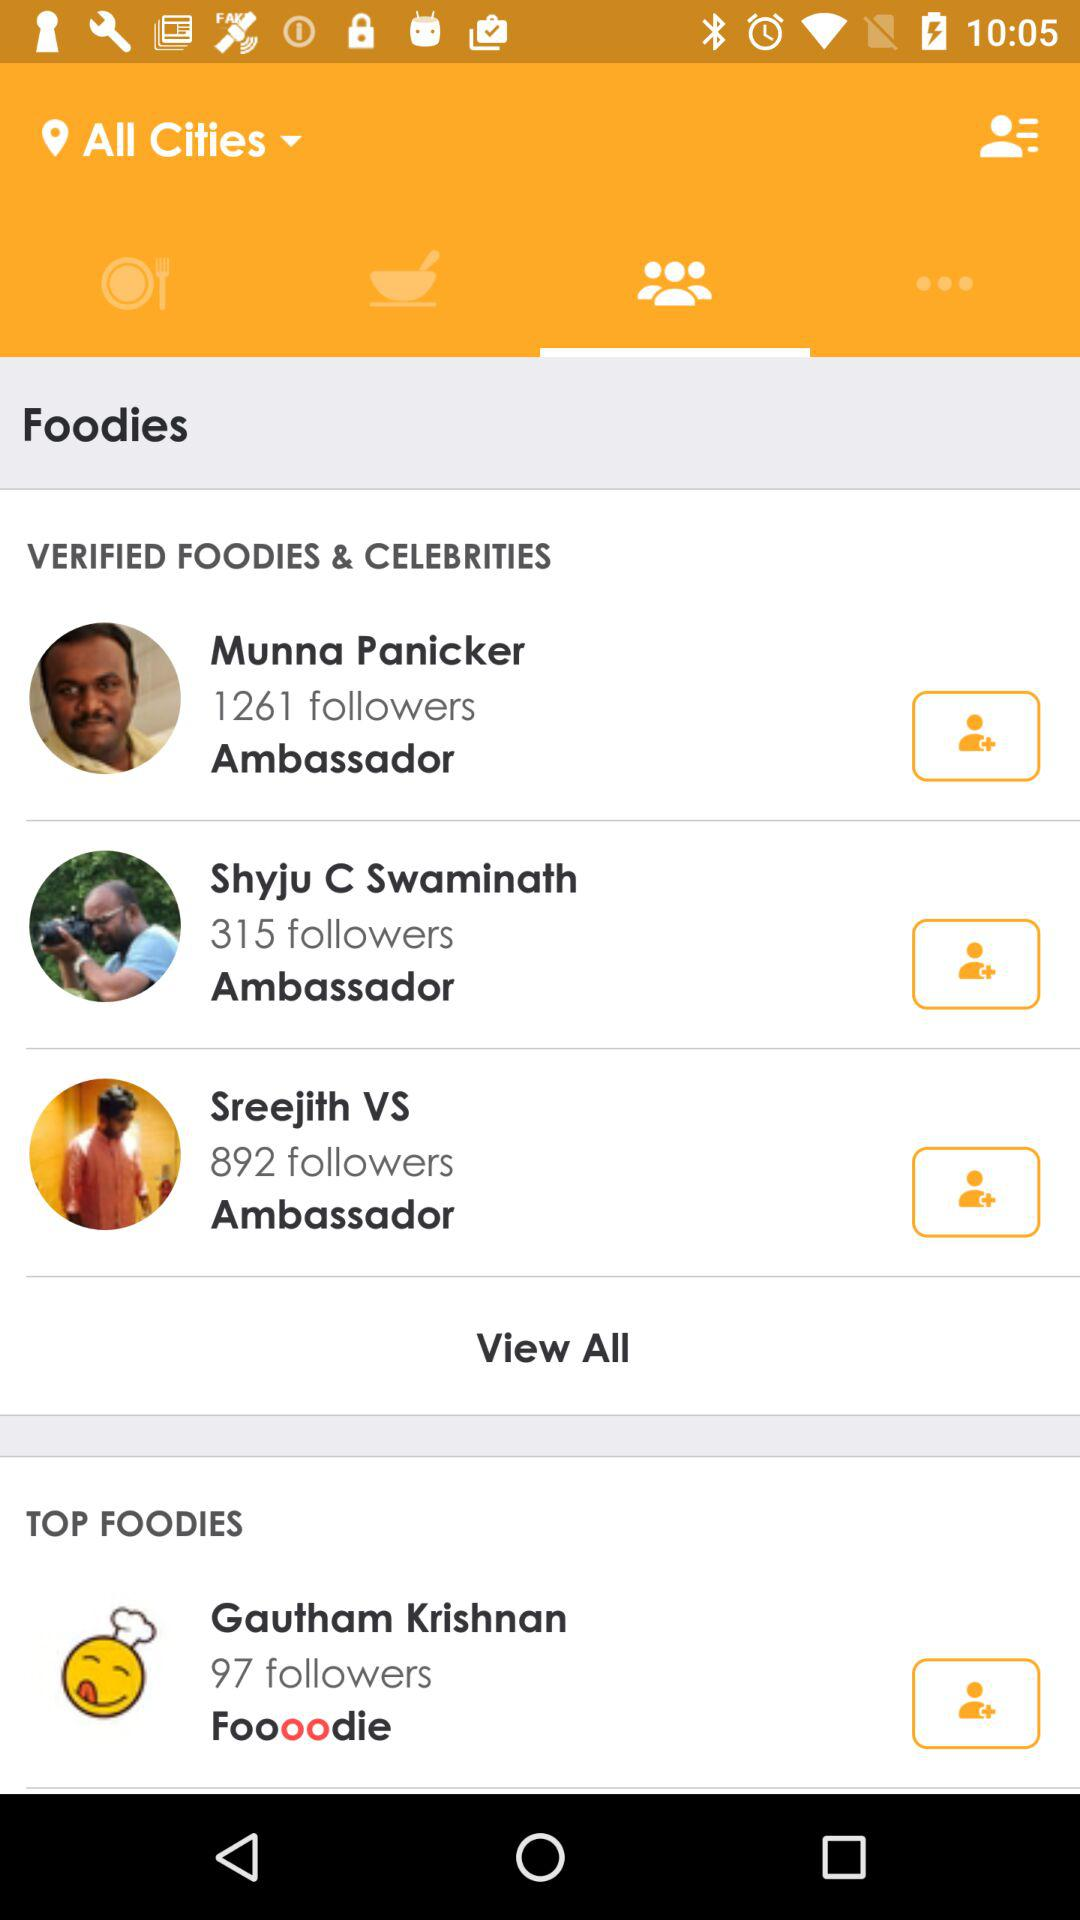How many more verified foodies are there than top foodies?
Answer the question using a single word or phrase. 2 